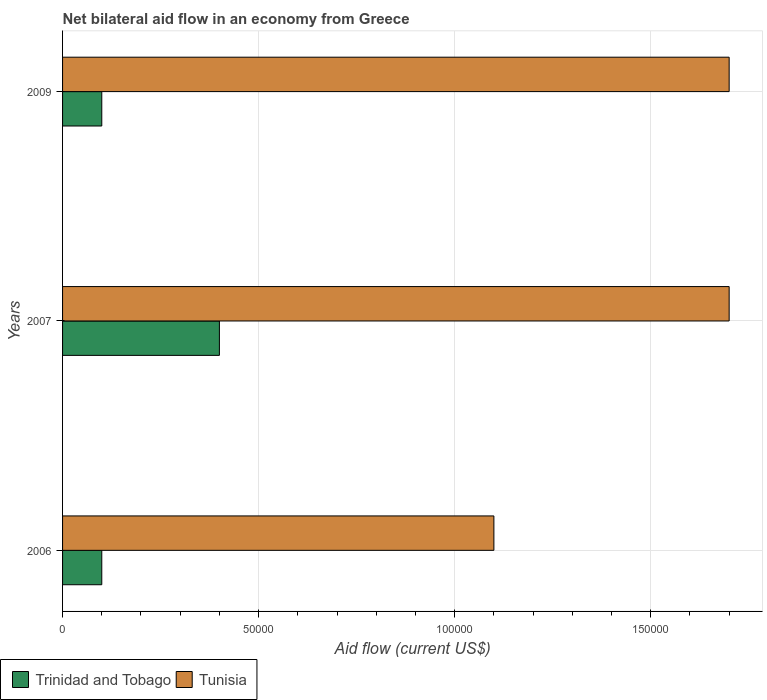How many bars are there on the 1st tick from the bottom?
Your answer should be very brief. 2. What is the label of the 2nd group of bars from the top?
Your answer should be very brief. 2007. In how many cases, is the number of bars for a given year not equal to the number of legend labels?
Give a very brief answer. 0. What is the net bilateral aid flow in Tunisia in 2006?
Give a very brief answer. 1.10e+05. Across all years, what is the maximum net bilateral aid flow in Tunisia?
Offer a very short reply. 1.70e+05. Across all years, what is the minimum net bilateral aid flow in Trinidad and Tobago?
Provide a short and direct response. 10000. In which year was the net bilateral aid flow in Tunisia minimum?
Your answer should be compact. 2006. What is the total net bilateral aid flow in Tunisia in the graph?
Provide a succinct answer. 4.50e+05. In the year 2006, what is the difference between the net bilateral aid flow in Tunisia and net bilateral aid flow in Trinidad and Tobago?
Your answer should be very brief. 1.00e+05. What is the ratio of the net bilateral aid flow in Tunisia in 2007 to that in 2009?
Your answer should be compact. 1. Is the difference between the net bilateral aid flow in Tunisia in 2006 and 2007 greater than the difference between the net bilateral aid flow in Trinidad and Tobago in 2006 and 2007?
Make the answer very short. No. What is the difference between the highest and the second highest net bilateral aid flow in Tunisia?
Ensure brevity in your answer.  0. In how many years, is the net bilateral aid flow in Trinidad and Tobago greater than the average net bilateral aid flow in Trinidad and Tobago taken over all years?
Provide a succinct answer. 1. What does the 2nd bar from the top in 2007 represents?
Your response must be concise. Trinidad and Tobago. What does the 1st bar from the bottom in 2009 represents?
Your answer should be compact. Trinidad and Tobago. How many bars are there?
Your answer should be very brief. 6. Are all the bars in the graph horizontal?
Provide a short and direct response. Yes. Does the graph contain any zero values?
Provide a short and direct response. No. Does the graph contain grids?
Offer a terse response. Yes. Where does the legend appear in the graph?
Keep it short and to the point. Bottom left. How many legend labels are there?
Offer a very short reply. 2. How are the legend labels stacked?
Provide a short and direct response. Horizontal. What is the title of the graph?
Ensure brevity in your answer.  Net bilateral aid flow in an economy from Greece. What is the label or title of the Y-axis?
Give a very brief answer. Years. What is the Aid flow (current US$) in Tunisia in 2007?
Your response must be concise. 1.70e+05. Across all years, what is the maximum Aid flow (current US$) in Trinidad and Tobago?
Your answer should be compact. 4.00e+04. Across all years, what is the maximum Aid flow (current US$) of Tunisia?
Offer a very short reply. 1.70e+05. What is the difference between the Aid flow (current US$) in Trinidad and Tobago in 2006 and that in 2009?
Make the answer very short. 0. What is the difference between the Aid flow (current US$) in Trinidad and Tobago in 2007 and that in 2009?
Offer a very short reply. 3.00e+04. What is the difference between the Aid flow (current US$) of Trinidad and Tobago in 2006 and the Aid flow (current US$) of Tunisia in 2007?
Make the answer very short. -1.60e+05. What is the difference between the Aid flow (current US$) in Trinidad and Tobago in 2006 and the Aid flow (current US$) in Tunisia in 2009?
Make the answer very short. -1.60e+05. What is the average Aid flow (current US$) of Trinidad and Tobago per year?
Keep it short and to the point. 2.00e+04. What is the average Aid flow (current US$) in Tunisia per year?
Your response must be concise. 1.50e+05. In the year 2006, what is the difference between the Aid flow (current US$) of Trinidad and Tobago and Aid flow (current US$) of Tunisia?
Your answer should be very brief. -1.00e+05. In the year 2007, what is the difference between the Aid flow (current US$) of Trinidad and Tobago and Aid flow (current US$) of Tunisia?
Ensure brevity in your answer.  -1.30e+05. In the year 2009, what is the difference between the Aid flow (current US$) in Trinidad and Tobago and Aid flow (current US$) in Tunisia?
Offer a very short reply. -1.60e+05. What is the ratio of the Aid flow (current US$) of Tunisia in 2006 to that in 2007?
Provide a succinct answer. 0.65. What is the ratio of the Aid flow (current US$) of Trinidad and Tobago in 2006 to that in 2009?
Offer a very short reply. 1. What is the ratio of the Aid flow (current US$) of Tunisia in 2006 to that in 2009?
Your response must be concise. 0.65. What is the ratio of the Aid flow (current US$) in Trinidad and Tobago in 2007 to that in 2009?
Your answer should be very brief. 4. What is the ratio of the Aid flow (current US$) in Tunisia in 2007 to that in 2009?
Make the answer very short. 1. What is the difference between the highest and the second highest Aid flow (current US$) in Trinidad and Tobago?
Offer a terse response. 3.00e+04. What is the difference between the highest and the lowest Aid flow (current US$) in Tunisia?
Offer a terse response. 6.00e+04. 